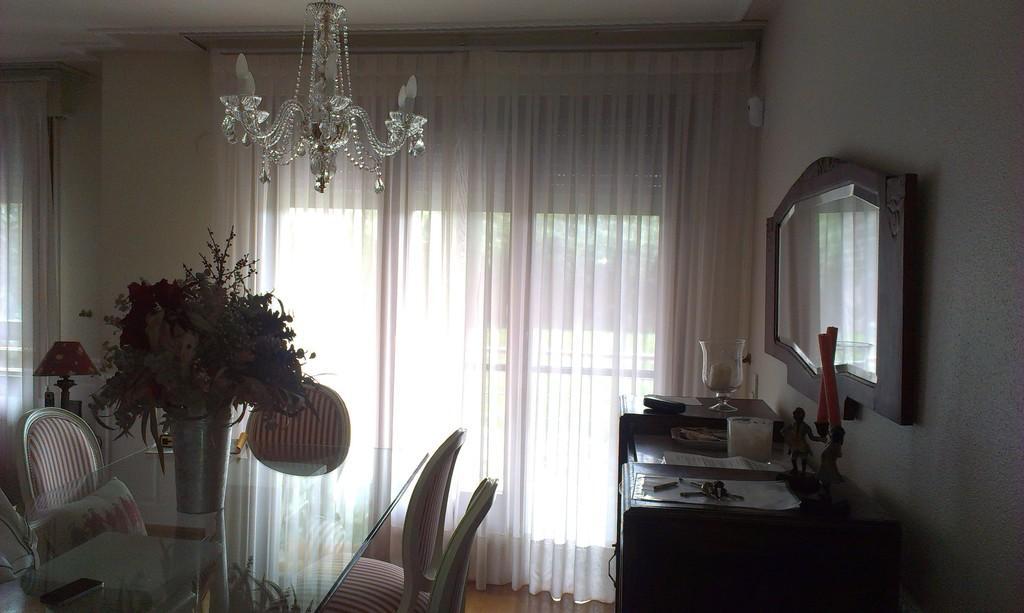Describe this image in one or two sentences. In this image there are few chairs surrounded by a table having a flower vase on it. Left side there is a lamp. Behind there is a window covered with curtain. Right side there is a table having few papers, lamp, candles and few objects are on it. A mirror is attached to the wall having window which is covered with curtain. 